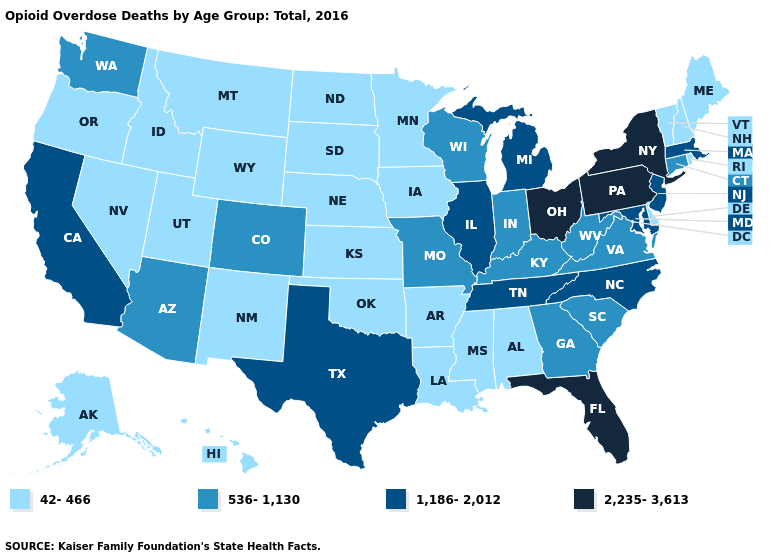Does Alabama have the same value as New Jersey?
Short answer required. No. What is the highest value in the USA?
Be succinct. 2,235-3,613. Name the states that have a value in the range 1,186-2,012?
Be succinct. California, Illinois, Maryland, Massachusetts, Michigan, New Jersey, North Carolina, Tennessee, Texas. What is the value of Colorado?
Concise answer only. 536-1,130. Is the legend a continuous bar?
Answer briefly. No. Does the first symbol in the legend represent the smallest category?
Give a very brief answer. Yes. What is the value of North Dakota?
Give a very brief answer. 42-466. Which states have the lowest value in the MidWest?
Give a very brief answer. Iowa, Kansas, Minnesota, Nebraska, North Dakota, South Dakota. Which states have the lowest value in the USA?
Keep it brief. Alabama, Alaska, Arkansas, Delaware, Hawaii, Idaho, Iowa, Kansas, Louisiana, Maine, Minnesota, Mississippi, Montana, Nebraska, Nevada, New Hampshire, New Mexico, North Dakota, Oklahoma, Oregon, Rhode Island, South Dakota, Utah, Vermont, Wyoming. Does Illinois have a higher value than Maine?
Be succinct. Yes. Does Kentucky have a higher value than Tennessee?
Quick response, please. No. What is the lowest value in the MidWest?
Short answer required. 42-466. What is the highest value in the USA?
Short answer required. 2,235-3,613. Which states have the highest value in the USA?
Be succinct. Florida, New York, Ohio, Pennsylvania. What is the lowest value in the USA?
Answer briefly. 42-466. 